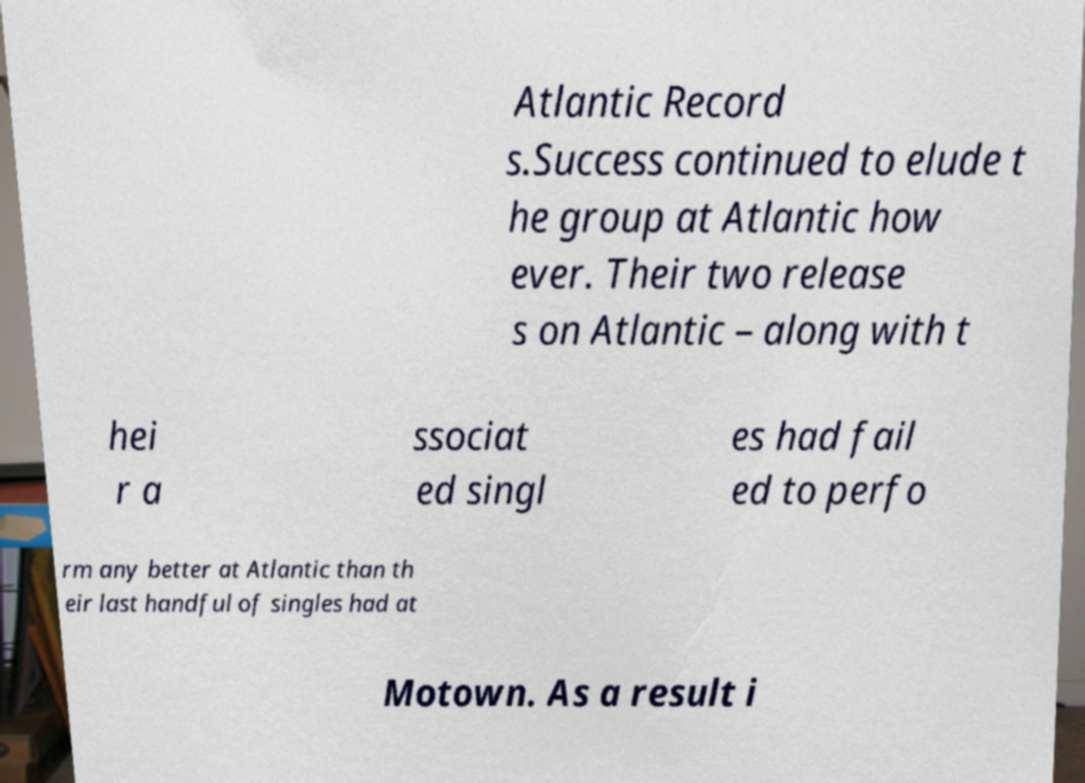Please identify and transcribe the text found in this image. Atlantic Record s.Success continued to elude t he group at Atlantic how ever. Their two release s on Atlantic – along with t hei r a ssociat ed singl es had fail ed to perfo rm any better at Atlantic than th eir last handful of singles had at Motown. As a result i 